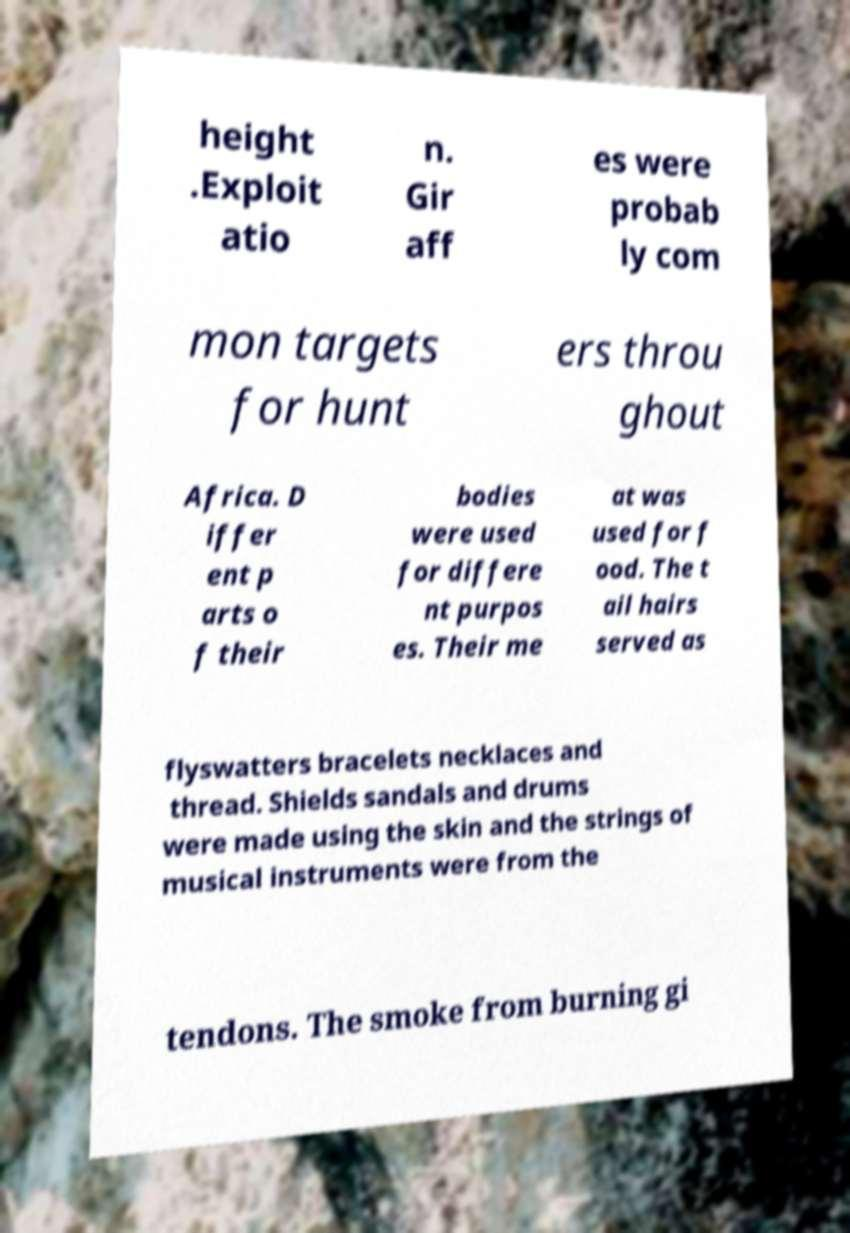Could you assist in decoding the text presented in this image and type it out clearly? height .Exploit atio n. Gir aff es were probab ly com mon targets for hunt ers throu ghout Africa. D iffer ent p arts o f their bodies were used for differe nt purpos es. Their me at was used for f ood. The t ail hairs served as flyswatters bracelets necklaces and thread. Shields sandals and drums were made using the skin and the strings of musical instruments were from the tendons. The smoke from burning gi 